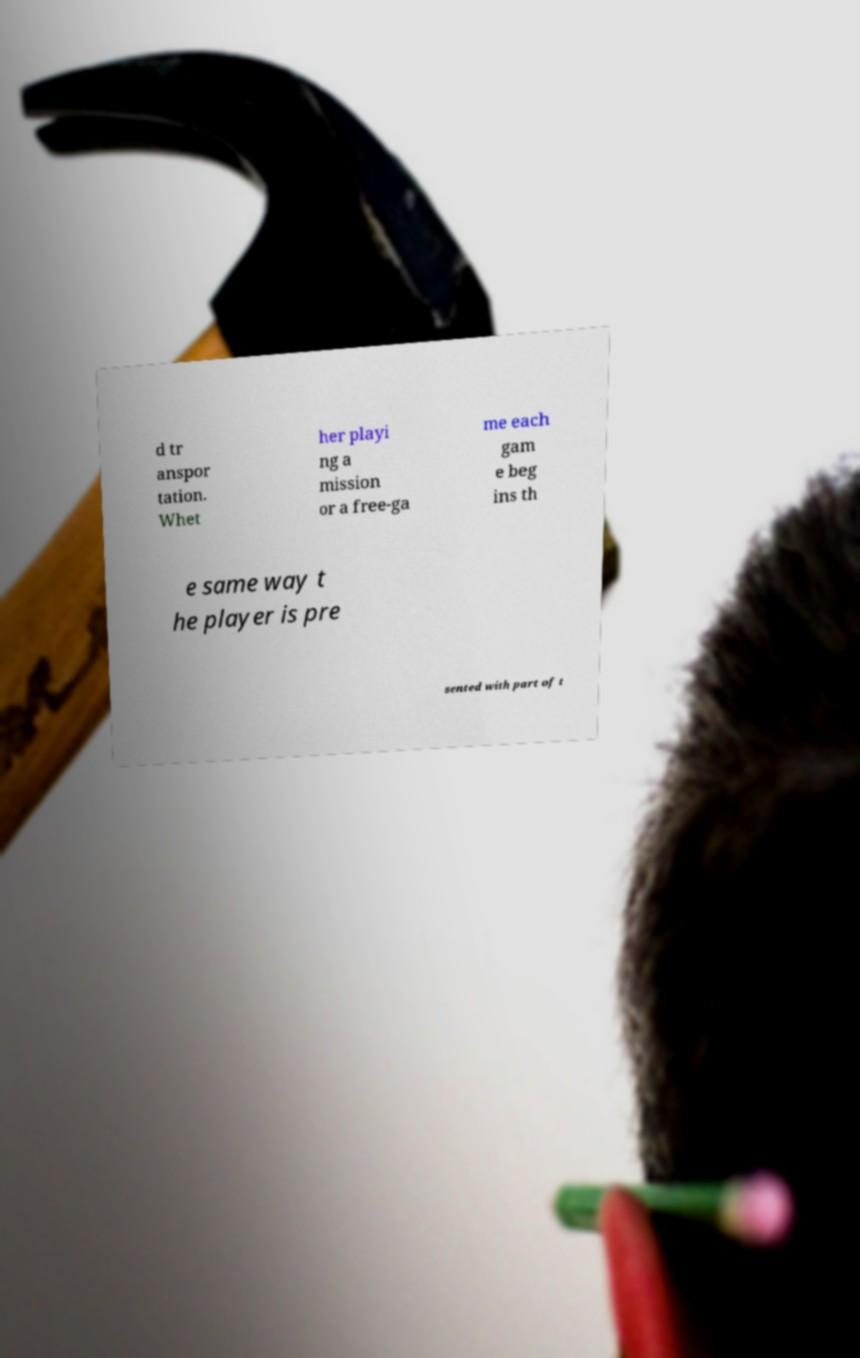What messages or text are displayed in this image? I need them in a readable, typed format. d tr anspor tation. Whet her playi ng a mission or a free-ga me each gam e beg ins th e same way t he player is pre sented with part of t 